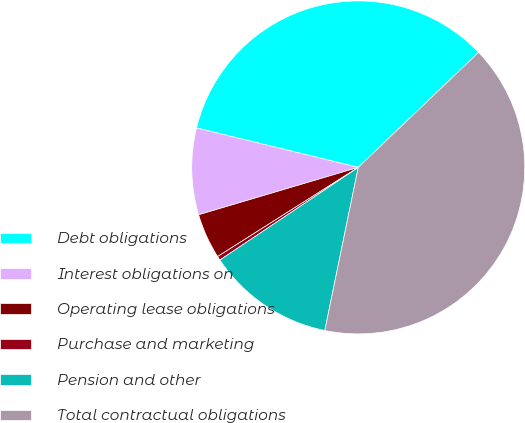<chart> <loc_0><loc_0><loc_500><loc_500><pie_chart><fcel>Debt obligations<fcel>Interest obligations on<fcel>Operating lease obligations<fcel>Purchase and marketing<fcel>Pension and other<fcel>Total contractual obligations<nl><fcel>34.05%<fcel>8.4%<fcel>4.4%<fcel>0.4%<fcel>12.39%<fcel>40.36%<nl></chart> 